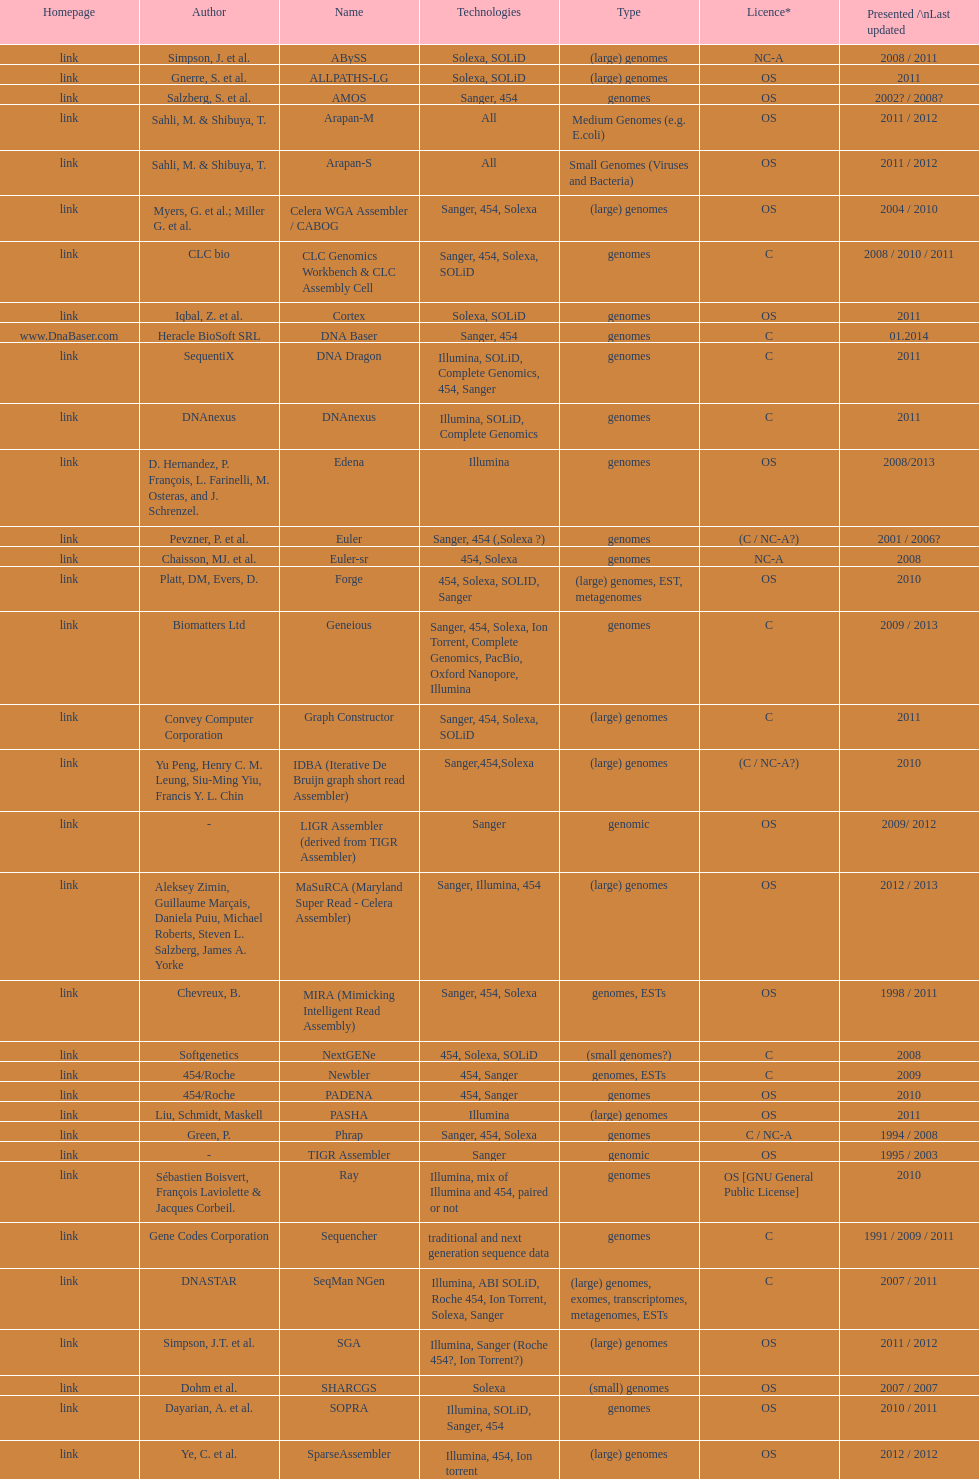Could you parse the entire table? {'header': ['Homepage', 'Author', 'Name', 'Technologies', 'Type', 'Licence*', 'Presented /\\nLast updated'], 'rows': [['link', 'Simpson, J. et al.', 'ABySS', 'Solexa, SOLiD', '(large) genomes', 'NC-A', '2008 / 2011'], ['link', 'Gnerre, S. et al.', 'ALLPATHS-LG', 'Solexa, SOLiD', '(large) genomes', 'OS', '2011'], ['link', 'Salzberg, S. et al.', 'AMOS', 'Sanger, 454', 'genomes', 'OS', '2002? / 2008?'], ['link', 'Sahli, M. & Shibuya, T.', 'Arapan-M', 'All', 'Medium Genomes (e.g. E.coli)', 'OS', '2011 / 2012'], ['link', 'Sahli, M. & Shibuya, T.', 'Arapan-S', 'All', 'Small Genomes (Viruses and Bacteria)', 'OS', '2011 / 2012'], ['link', 'Myers, G. et al.; Miller G. et al.', 'Celera WGA Assembler / CABOG', 'Sanger, 454, Solexa', '(large) genomes', 'OS', '2004 / 2010'], ['link', 'CLC bio', 'CLC Genomics Workbench & CLC Assembly Cell', 'Sanger, 454, Solexa, SOLiD', 'genomes', 'C', '2008 / 2010 / 2011'], ['link', 'Iqbal, Z. et al.', 'Cortex', 'Solexa, SOLiD', 'genomes', 'OS', '2011'], ['www.DnaBaser.com', 'Heracle BioSoft SRL', 'DNA Baser', 'Sanger, 454', 'genomes', 'C', '01.2014'], ['link', 'SequentiX', 'DNA Dragon', 'Illumina, SOLiD, Complete Genomics, 454, Sanger', 'genomes', 'C', '2011'], ['link', 'DNAnexus', 'DNAnexus', 'Illumina, SOLiD, Complete Genomics', 'genomes', 'C', '2011'], ['link', 'D. Hernandez, P. François, L. Farinelli, M. Osteras, and J. Schrenzel.', 'Edena', 'Illumina', 'genomes', 'OS', '2008/2013'], ['link', 'Pevzner, P. et al.', 'Euler', 'Sanger, 454 (,Solexa\xa0?)', 'genomes', '(C / NC-A?)', '2001 / 2006?'], ['link', 'Chaisson, MJ. et al.', 'Euler-sr', '454, Solexa', 'genomes', 'NC-A', '2008'], ['link', 'Platt, DM, Evers, D.', 'Forge', '454, Solexa, SOLID, Sanger', '(large) genomes, EST, metagenomes', 'OS', '2010'], ['link', 'Biomatters Ltd', 'Geneious', 'Sanger, 454, Solexa, Ion Torrent, Complete Genomics, PacBio, Oxford Nanopore, Illumina', 'genomes', 'C', '2009 / 2013'], ['link', 'Convey Computer Corporation', 'Graph Constructor', 'Sanger, 454, Solexa, SOLiD', '(large) genomes', 'C', '2011'], ['link', 'Yu Peng, Henry C. M. Leung, Siu-Ming Yiu, Francis Y. L. Chin', 'IDBA (Iterative De Bruijn graph short read Assembler)', 'Sanger,454,Solexa', '(large) genomes', '(C / NC-A?)', '2010'], ['link', '-', 'LIGR Assembler (derived from TIGR Assembler)', 'Sanger', 'genomic', 'OS', '2009/ 2012'], ['link', 'Aleksey Zimin, Guillaume Marçais, Daniela Puiu, Michael Roberts, Steven L. Salzberg, James A. Yorke', 'MaSuRCA (Maryland Super Read - Celera Assembler)', 'Sanger, Illumina, 454', '(large) genomes', 'OS', '2012 / 2013'], ['link', 'Chevreux, B.', 'MIRA (Mimicking Intelligent Read Assembly)', 'Sanger, 454, Solexa', 'genomes, ESTs', 'OS', '1998 / 2011'], ['link', 'Softgenetics', 'NextGENe', '454, Solexa, SOLiD', '(small genomes?)', 'C', '2008'], ['link', '454/Roche', 'Newbler', '454, Sanger', 'genomes, ESTs', 'C', '2009'], ['link', '454/Roche', 'PADENA', '454, Sanger', 'genomes', 'OS', '2010'], ['link', 'Liu, Schmidt, Maskell', 'PASHA', 'Illumina', '(large) genomes', 'OS', '2011'], ['link', 'Green, P.', 'Phrap', 'Sanger, 454, Solexa', 'genomes', 'C / NC-A', '1994 / 2008'], ['link', '-', 'TIGR Assembler', 'Sanger', 'genomic', 'OS', '1995 / 2003'], ['link', 'Sébastien Boisvert, François Laviolette & Jacques Corbeil.', 'Ray', 'Illumina, mix of Illumina and 454, paired or not', 'genomes', 'OS [GNU General Public License]', '2010'], ['link', 'Gene Codes Corporation', 'Sequencher', 'traditional and next generation sequence data', 'genomes', 'C', '1991 / 2009 / 2011'], ['link', 'DNASTAR', 'SeqMan NGen', 'Illumina, ABI SOLiD, Roche 454, Ion Torrent, Solexa, Sanger', '(large) genomes, exomes, transcriptomes, metagenomes, ESTs', 'C', '2007 / 2011'], ['link', 'Simpson, J.T. et al.', 'SGA', 'Illumina, Sanger (Roche 454?, Ion Torrent?)', '(large) genomes', 'OS', '2011 / 2012'], ['link', 'Dohm et al.', 'SHARCGS', 'Solexa', '(small) genomes', 'OS', '2007 / 2007'], ['link', 'Dayarian, A. et al.', 'SOPRA', 'Illumina, SOLiD, Sanger, 454', 'genomes', 'OS', '2010 / 2011'], ['link', 'Ye, C. et al.', 'SparseAssembler', 'Illumina, 454, Ion torrent', '(large) genomes', 'OS', '2012 / 2012'], ['link', 'Warren, R. et al.', 'SSAKE', 'Solexa (SOLiD? Helicos?)', '(small) genomes', 'OS', '2007 / 2007'], ['link', 'Li, R. et al.', 'SOAPdenovo', 'Solexa', 'genomes', 'OS', '2009 / 2009'], ['link', 'Bankevich, A et al.', 'SPAdes', 'Illumina, Solexa', '(small) genomes, single-cell', 'OS', '2012 / 2013'], ['link', 'Staden et al.', 'Staden gap4 package', 'Sanger', 'BACs (, small genomes?)', 'OS', '1991 / 2008'], ['link', 'Schmidt, B. et al.', 'Taipan', 'Illumina', '(small) genomes', 'OS', '2009'], ['link', 'Jeck, W. et al.', 'VCAKE', 'Solexa (SOLiD?, Helicos?)', '(small) genomes', 'OS', '2007 / 2007'], ['link', 'Mullikin JC, et al.', 'Phusion assembler', 'Sanger', '(large) genomes', 'OS', '2003'], ['link', 'Bryant DW, et al.', 'Quality Value Guided SRA (QSRA)', 'Sanger, Solexa', 'genomes', 'OS', '2009'], ['link', 'Zerbino, D. et al.', 'Velvet', 'Sanger, 454, Solexa, SOLiD', '(small) genomes', 'OS', '2007 / 2009']]} What is the total number of assemblers supporting medium genomes type technologies? 1. 